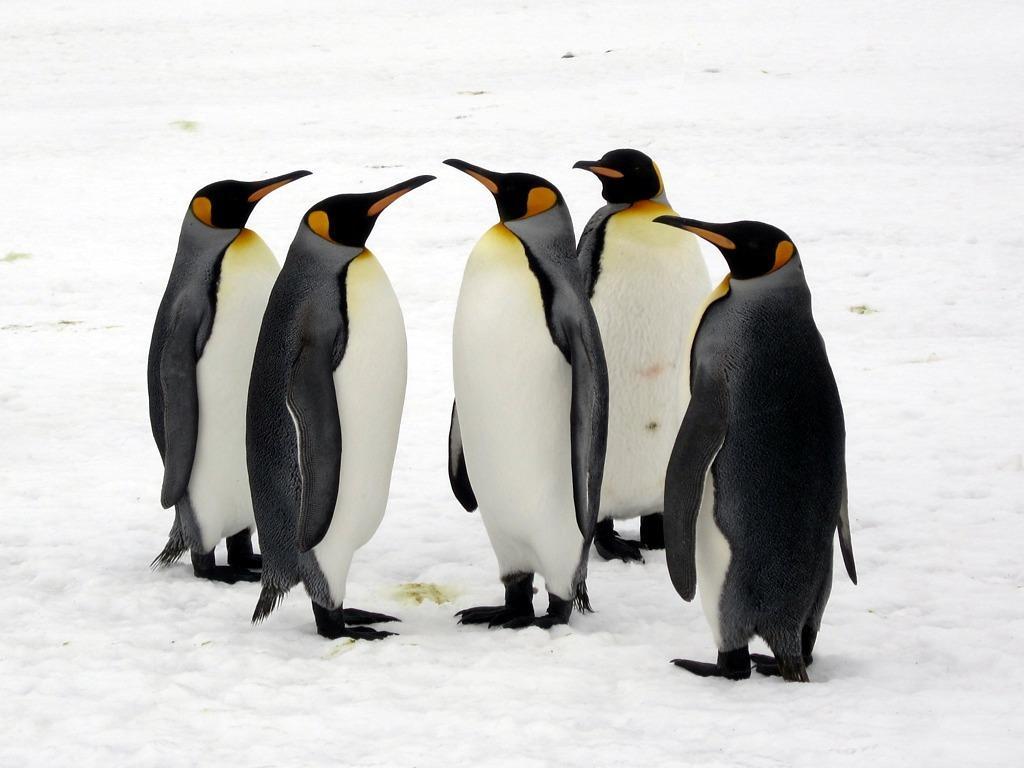Could you give a brief overview of what you see in this image? These are the 5 penguins in black and white color on the snow. 